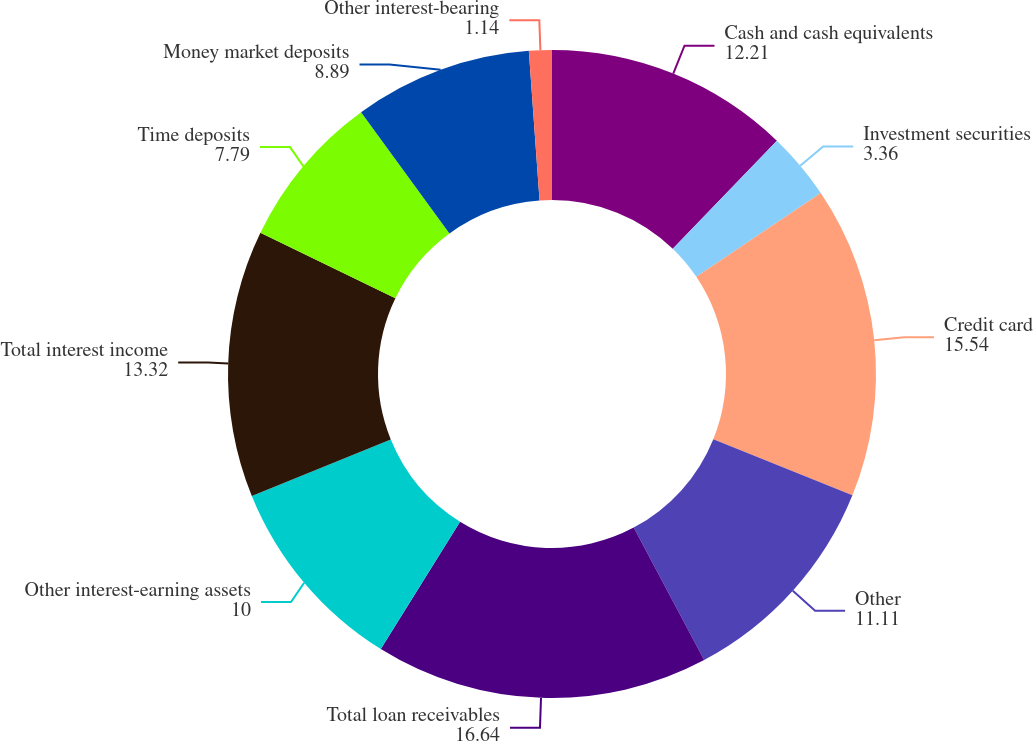Convert chart. <chart><loc_0><loc_0><loc_500><loc_500><pie_chart><fcel>Cash and cash equivalents<fcel>Investment securities<fcel>Credit card<fcel>Other<fcel>Total loan receivables<fcel>Other interest-earning assets<fcel>Total interest income<fcel>Time deposits<fcel>Money market deposits<fcel>Other interest-bearing<nl><fcel>12.21%<fcel>3.36%<fcel>15.54%<fcel>11.11%<fcel>16.64%<fcel>10.0%<fcel>13.32%<fcel>7.79%<fcel>8.89%<fcel>1.14%<nl></chart> 